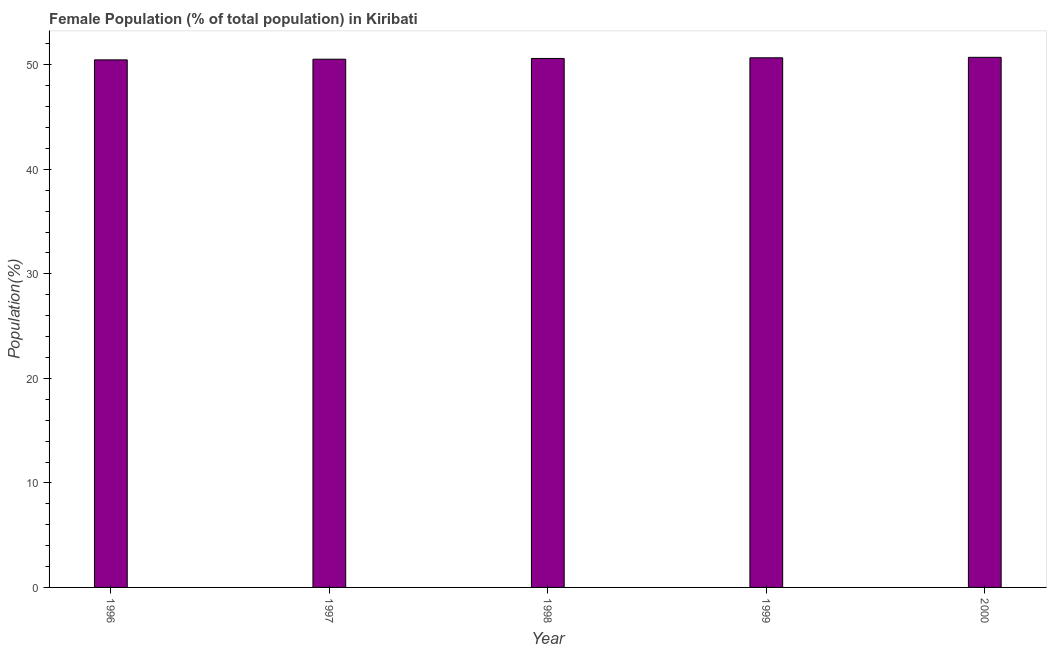What is the title of the graph?
Offer a terse response. Female Population (% of total population) in Kiribati. What is the label or title of the X-axis?
Your response must be concise. Year. What is the label or title of the Y-axis?
Keep it short and to the point. Population(%). What is the female population in 1999?
Keep it short and to the point. 50.67. Across all years, what is the maximum female population?
Provide a succinct answer. 50.72. Across all years, what is the minimum female population?
Provide a short and direct response. 50.48. In which year was the female population minimum?
Keep it short and to the point. 1996. What is the sum of the female population?
Your answer should be very brief. 253.02. What is the difference between the female population in 1998 and 2000?
Ensure brevity in your answer.  -0.11. What is the average female population per year?
Provide a short and direct response. 50.6. What is the median female population?
Give a very brief answer. 50.61. Do a majority of the years between 1997 and 1996 (inclusive) have female population greater than 24 %?
Ensure brevity in your answer.  No. What is the ratio of the female population in 1999 to that in 2000?
Offer a terse response. 1. Is the female population in 1998 less than that in 1999?
Provide a succinct answer. Yes. Is the difference between the female population in 1997 and 2000 greater than the difference between any two years?
Ensure brevity in your answer.  No. What is the difference between the highest and the second highest female population?
Your response must be concise. 0.04. What is the difference between the highest and the lowest female population?
Your answer should be compact. 0.24. In how many years, is the female population greater than the average female population taken over all years?
Provide a short and direct response. 3. How many bars are there?
Your answer should be compact. 5. Are all the bars in the graph horizontal?
Provide a succinct answer. No. How many years are there in the graph?
Offer a very short reply. 5. What is the difference between two consecutive major ticks on the Y-axis?
Ensure brevity in your answer.  10. Are the values on the major ticks of Y-axis written in scientific E-notation?
Ensure brevity in your answer.  No. What is the Population(%) of 1996?
Give a very brief answer. 50.48. What is the Population(%) of 1997?
Your answer should be very brief. 50.54. What is the Population(%) in 1998?
Offer a terse response. 50.61. What is the Population(%) of 1999?
Offer a very short reply. 50.67. What is the Population(%) in 2000?
Your answer should be compact. 50.72. What is the difference between the Population(%) in 1996 and 1997?
Provide a short and direct response. -0.06. What is the difference between the Population(%) in 1996 and 1998?
Give a very brief answer. -0.13. What is the difference between the Population(%) in 1996 and 1999?
Your response must be concise. -0.2. What is the difference between the Population(%) in 1996 and 2000?
Offer a very short reply. -0.24. What is the difference between the Population(%) in 1997 and 1998?
Ensure brevity in your answer.  -0.07. What is the difference between the Population(%) in 1997 and 1999?
Offer a terse response. -0.14. What is the difference between the Population(%) in 1997 and 2000?
Offer a terse response. -0.18. What is the difference between the Population(%) in 1998 and 1999?
Your answer should be compact. -0.06. What is the difference between the Population(%) in 1998 and 2000?
Provide a succinct answer. -0.11. What is the difference between the Population(%) in 1999 and 2000?
Keep it short and to the point. -0.04. What is the ratio of the Population(%) in 1996 to that in 1997?
Keep it short and to the point. 1. What is the ratio of the Population(%) in 1996 to that in 1998?
Provide a succinct answer. 1. What is the ratio of the Population(%) in 1997 to that in 1999?
Provide a succinct answer. 1. What is the ratio of the Population(%) in 1997 to that in 2000?
Make the answer very short. 1. What is the ratio of the Population(%) in 1998 to that in 2000?
Offer a terse response. 1. 